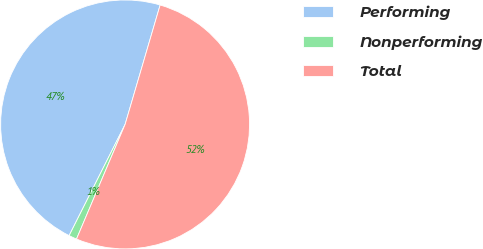<chart> <loc_0><loc_0><loc_500><loc_500><pie_chart><fcel>Performing<fcel>Nonperforming<fcel>Total<nl><fcel>47.12%<fcel>1.04%<fcel>51.84%<nl></chart> 